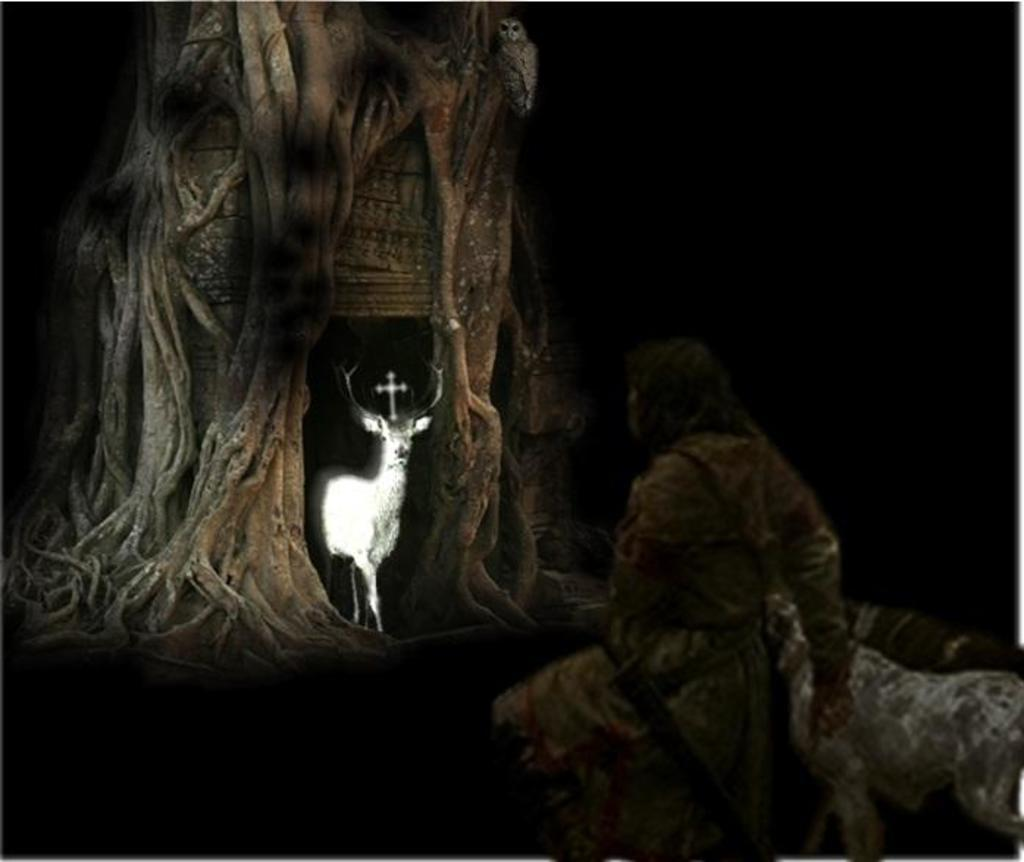How was the image altered or modified? The image is edited, which means it has been altered or modified in some way. What type of animal can be seen in the image? There is an animal in the image, but the specific type of animal is not mentioned in the facts. What natural element is present in the image? There is a tree in the image. Who or what else is present in the image? There is a person in the image. How many tomatoes are hanging from the tree in the image? There is no mention of tomatoes in the image, so it is not possible to determine how many there might be. 